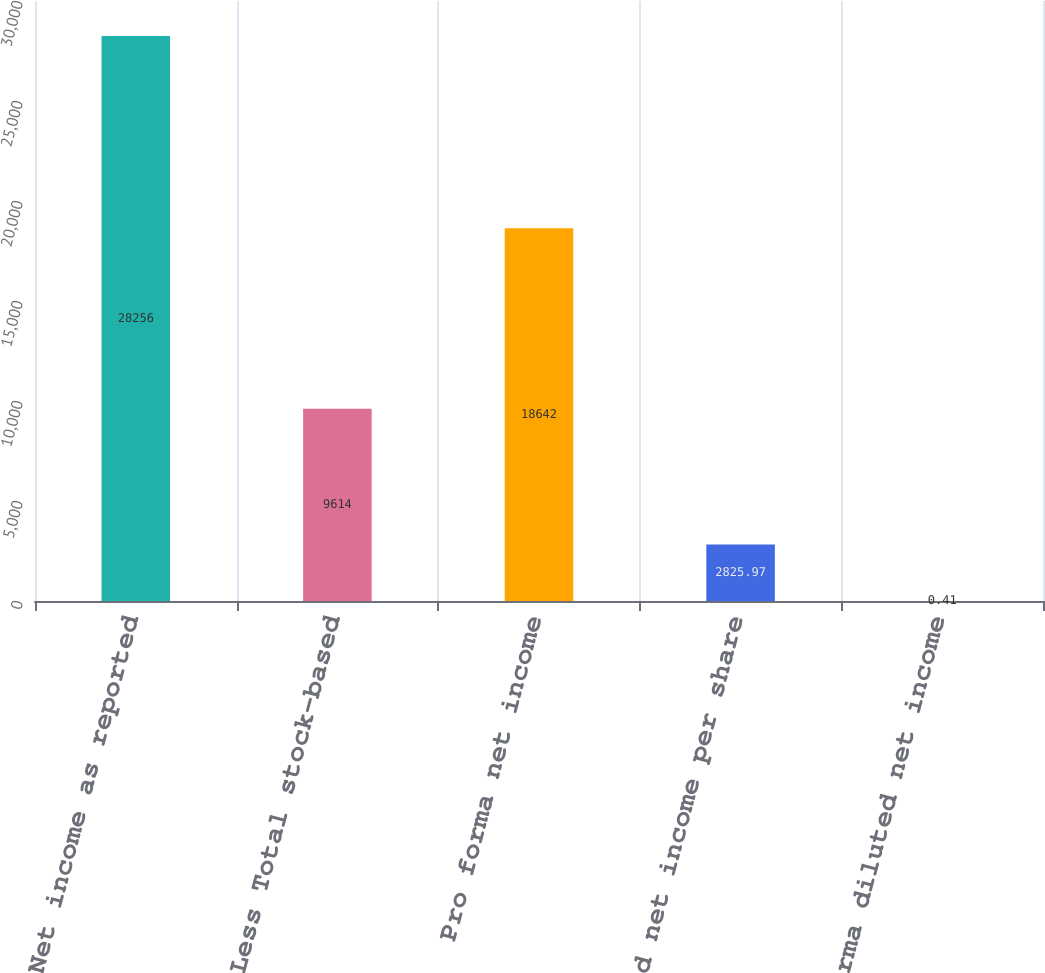<chart> <loc_0><loc_0><loc_500><loc_500><bar_chart><fcel>Net income as reported<fcel>Less Total stock-based<fcel>Pro forma net income<fcel>Diluted net income per share<fcel>Pro forma diluted net income<nl><fcel>28256<fcel>9614<fcel>18642<fcel>2825.97<fcel>0.41<nl></chart> 